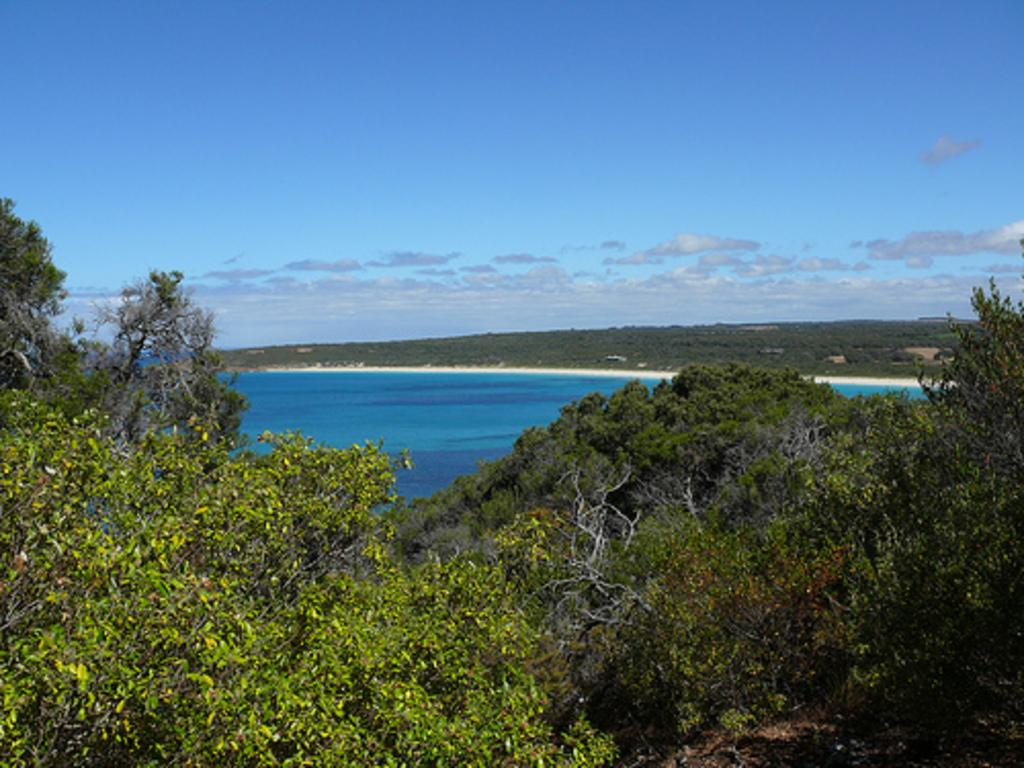What type of vegetation can be seen in the image? There are trees in the image. What natural element is visible besides the trees? There is water visible in the image. What can be seen in the background of the image? The sky is visible in the background of the image. What type of cork can be seen floating on the water in the image? There is no cork visible in the image; only trees, water, and the sky are present. 